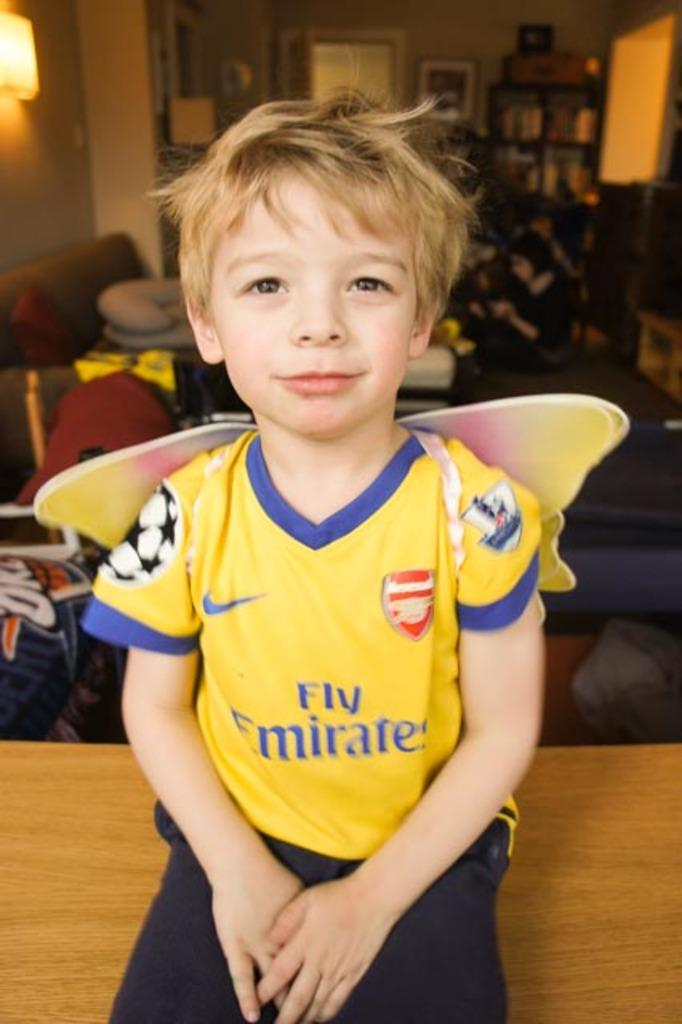<image>
Render a clear and concise summary of the photo. Boy wearing a yellow shirt that says Fly emirates. 